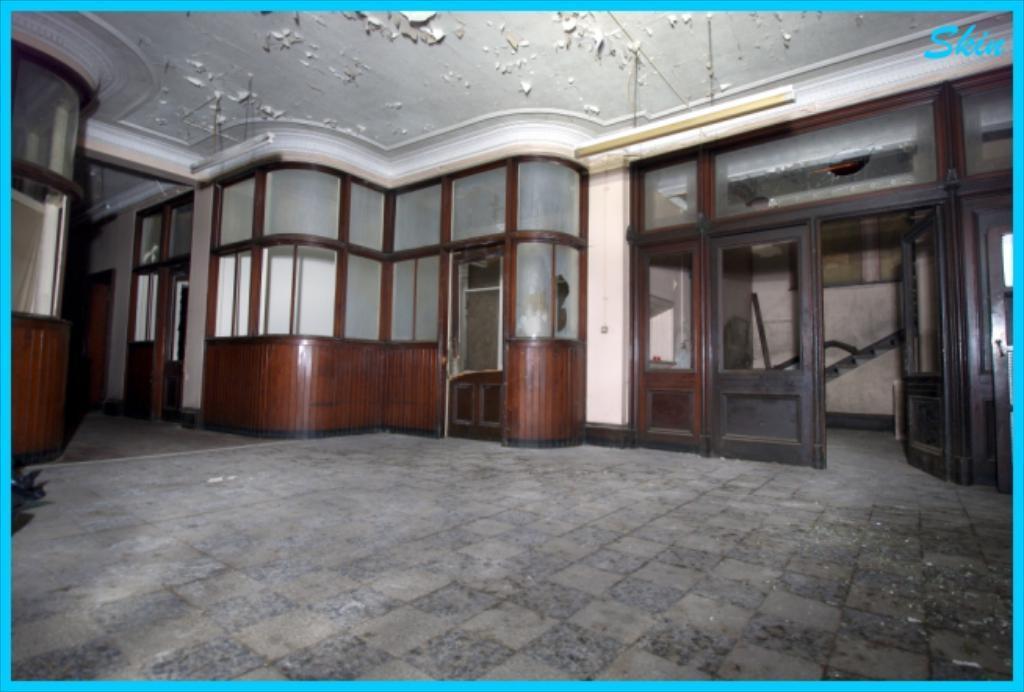In one or two sentences, can you explain what this image depicts? In this image I can see inside view of the houses and I can see doors and the wall, roof visible in the middle. 